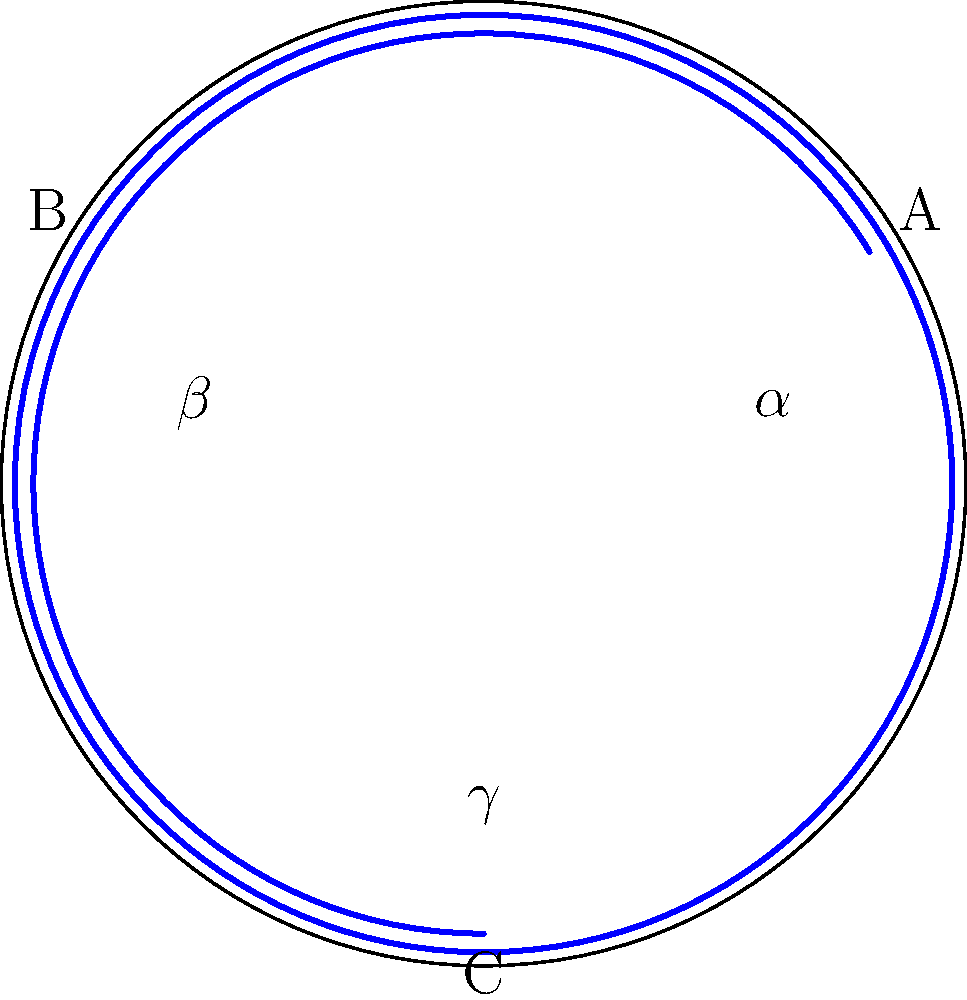Consider a spherical triangle ABC on the surface of a sphere, as shown in the diagram. If the sum of the interior angles ($\alpha + \beta + \gamma$) is 270°, what is the area of this triangle in terms of $R^2$, where R is the radius of the sphere? To solve this problem, we'll use the following steps:

1) Recall the formula for the area of a spherical triangle:
   $A = R^2(\alpha + \beta + \gamma - \pi)$
   where $A$ is the area, $R$ is the radius of the sphere, and $\alpha$, $\beta$, and $\gamma$ are the angles in radians.

2) We're given that $\alpha + \beta + \gamma = 270°$. Let's convert this to radians:
   $270° = 270 \cdot \frac{\pi}{180} = \frac{3\pi}{2}$ radians

3) Now, let's substitute this into our area formula:
   $A = R^2(\frac{3\pi}{2} - \pi)$

4) Simplify:
   $A = R^2(\frac{\pi}{2})$

5) This can be written as:
   $A = \frac{1}{2}\pi R^2$

Therefore, the area of the spherical triangle is $\frac{1}{2}\pi R^2$.

This result demonstrates how the curvature of space on a spherical surface impacts the properties of triangles. Unlike in Euclidean geometry, the sum of angles in a spherical triangle is always greater than 180°, and this excess directly relates to the triangle's area.
Answer: $\frac{1}{2}\pi R^2$ 